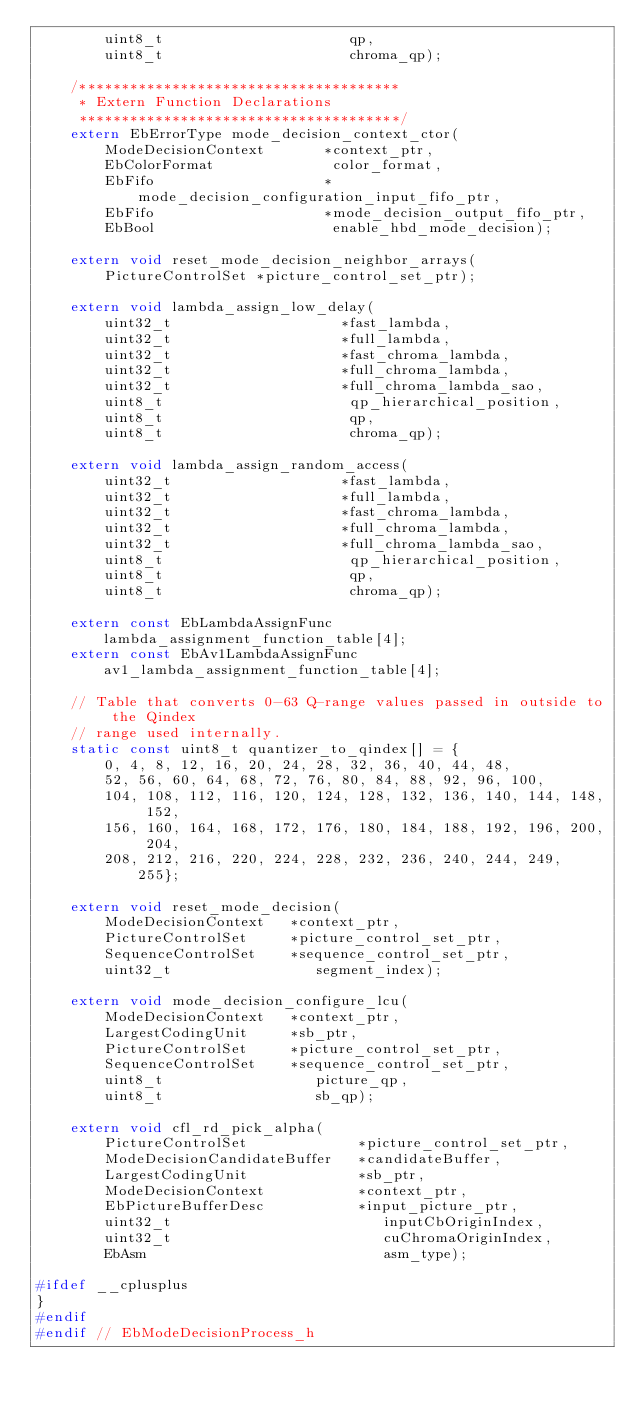Convert code to text. <code><loc_0><loc_0><loc_500><loc_500><_C_>        uint8_t                      qp,
        uint8_t                      chroma_qp);

    /**************************************
     * Extern Function Declarations
     **************************************/
    extern EbErrorType mode_decision_context_ctor(
        ModeDecisionContext       *context_ptr,
        EbColorFormat              color_format,
        EbFifo                    *mode_decision_configuration_input_fifo_ptr,
        EbFifo                    *mode_decision_output_fifo_ptr,
        EbBool                     enable_hbd_mode_decision);

    extern void reset_mode_decision_neighbor_arrays(
        PictureControlSet *picture_control_set_ptr);

    extern void lambda_assign_low_delay(
        uint32_t                    *fast_lambda,
        uint32_t                    *full_lambda,
        uint32_t                    *fast_chroma_lambda,
        uint32_t                    *full_chroma_lambda,
        uint32_t                    *full_chroma_lambda_sao,
        uint8_t                      qp_hierarchical_position,
        uint8_t                      qp,
        uint8_t                      chroma_qp);

    extern void lambda_assign_random_access(
        uint32_t                    *fast_lambda,
        uint32_t                    *full_lambda,
        uint32_t                    *fast_chroma_lambda,
        uint32_t                    *full_chroma_lambda,
        uint32_t                    *full_chroma_lambda_sao,
        uint8_t                      qp_hierarchical_position,
        uint8_t                      qp,
        uint8_t                      chroma_qp);

    extern const EbLambdaAssignFunc     lambda_assignment_function_table[4];
    extern const EbAv1LambdaAssignFunc av1_lambda_assignment_function_table[4];

    // Table that converts 0-63 Q-range values passed in outside to the Qindex
    // range used internally.
    static const uint8_t quantizer_to_qindex[] = {
        0, 4, 8, 12, 16, 20, 24, 28, 32, 36, 40, 44, 48,
        52, 56, 60, 64, 68, 72, 76, 80, 84, 88, 92, 96, 100,
        104, 108, 112, 116, 120, 124, 128, 132, 136, 140, 144, 148, 152,
        156, 160, 164, 168, 172, 176, 180, 184, 188, 192, 196, 200, 204,
        208, 212, 216, 220, 224, 228, 232, 236, 240, 244, 249, 255};

    extern void reset_mode_decision(
        ModeDecisionContext   *context_ptr,
        PictureControlSet     *picture_control_set_ptr,
        SequenceControlSet    *sequence_control_set_ptr,
        uint32_t                 segment_index);

    extern void mode_decision_configure_lcu(
        ModeDecisionContext   *context_ptr,
        LargestCodingUnit     *sb_ptr,
        PictureControlSet     *picture_control_set_ptr,
        SequenceControlSet    *sequence_control_set_ptr,
        uint8_t                  picture_qp,
        uint8_t                  sb_qp);

    extern void cfl_rd_pick_alpha(
        PictureControlSet             *picture_control_set_ptr,
        ModeDecisionCandidateBuffer   *candidateBuffer,
        LargestCodingUnit             *sb_ptr,
        ModeDecisionContext           *context_ptr,
        EbPictureBufferDesc           *input_picture_ptr,
        uint32_t                         inputCbOriginIndex,
        uint32_t                         cuChromaOriginIndex,
        EbAsm                            asm_type);

#ifdef __cplusplus
}
#endif
#endif // EbModeDecisionProcess_h
</code> 